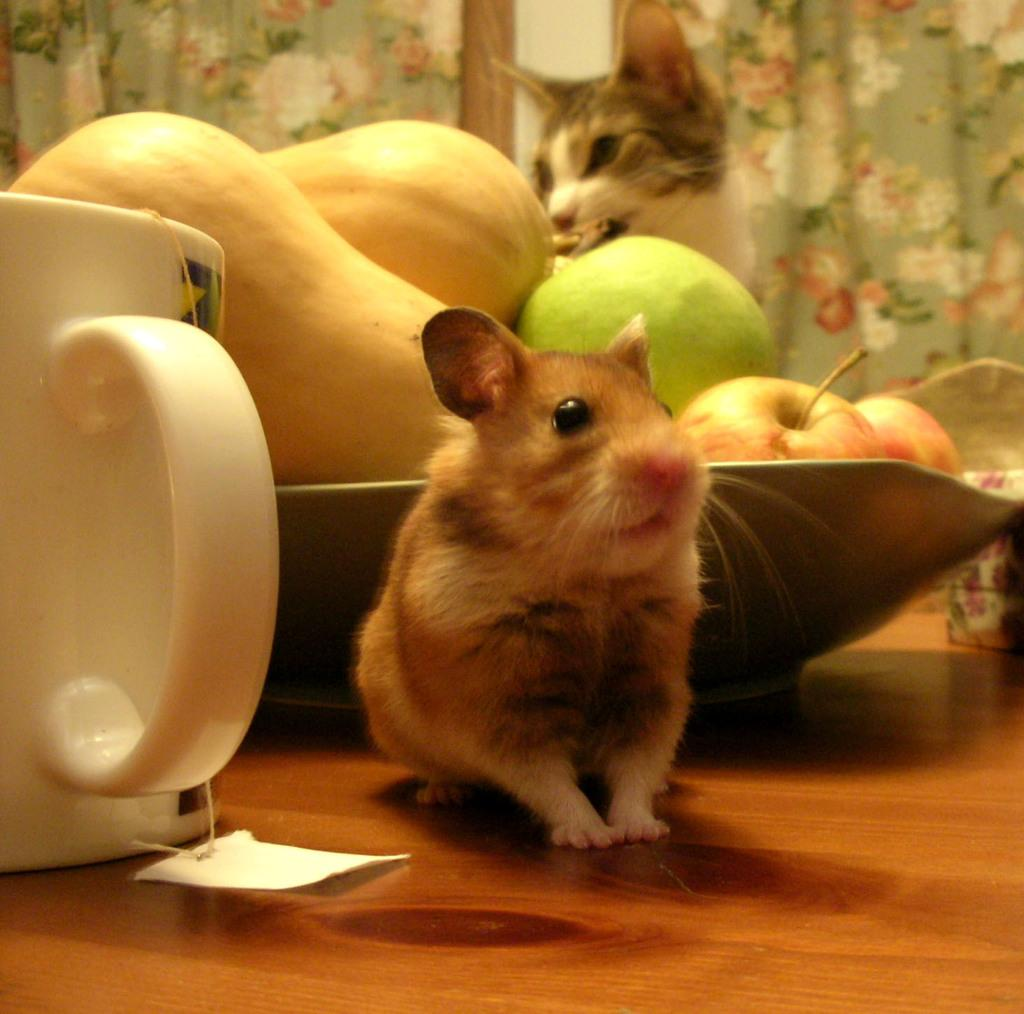What is the main subject on the wooden surface in the image? There is a hamster on a wooden surface in the image. What else can be seen on the wooden surface? There is a cup and a tray with fruits on the wooden surface. What is visible in the background of the image? There is a cat and curtains in the background. How much money is the hamster holding in the image? The hamster is not holding any money in the image. Hamsters do not have the ability to hold or use money. 